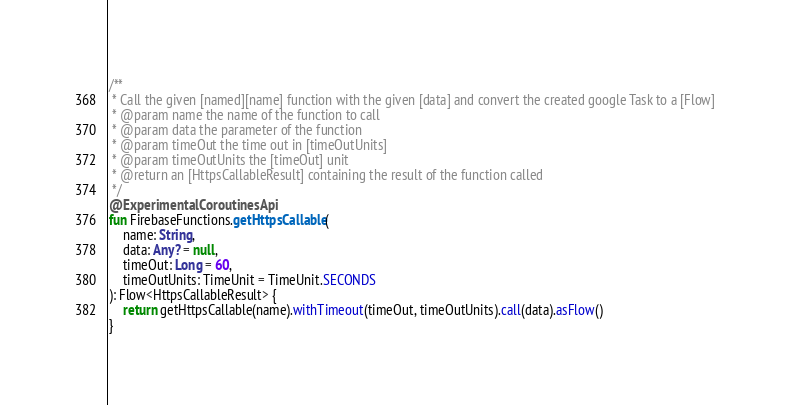<code> <loc_0><loc_0><loc_500><loc_500><_Kotlin_>
/**
 * Call the given [named][name] function with the given [data] and convert the created google Task to a [Flow]
 * @param name the name of the function to call
 * @param data the parameter of the function
 * @param timeOut the time out in [timeOutUnits]
 * @param timeOutUnits the [timeOut] unit
 * @return an [HttpsCallableResult] containing the result of the function called
 */
@ExperimentalCoroutinesApi
fun FirebaseFunctions.getHttpsCallable(
    name: String,
    data: Any? = null,
    timeOut: Long = 60,
    timeOutUnits: TimeUnit = TimeUnit.SECONDS
): Flow<HttpsCallableResult> {
    return getHttpsCallable(name).withTimeout(timeOut, timeOutUnits).call(data).asFlow()
}</code> 